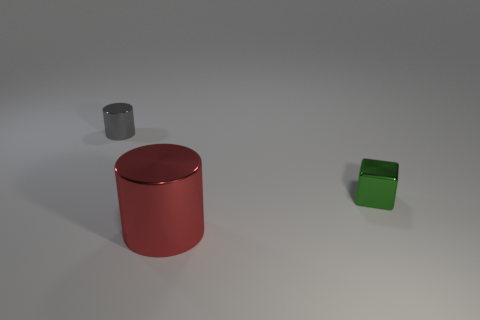What number of rubber things are either cylinders or red objects?
Your answer should be compact. 0. Is the material of the green thing the same as the large red object?
Give a very brief answer. Yes. There is a cylinder right of the metal thing behind the small green block; what is its material?
Your response must be concise. Metal. What number of large things are blue matte things or metallic blocks?
Provide a short and direct response. 0. What size is the gray thing?
Your answer should be compact. Small. Are there more shiny objects right of the small cube than red metallic objects?
Offer a very short reply. No. Are there the same number of large red cylinders behind the gray metallic cylinder and tiny green shiny blocks to the right of the green thing?
Your response must be concise. Yes. What color is the shiny thing that is both to the right of the small gray cylinder and on the left side of the small cube?
Offer a very short reply. Red. Is there anything else that has the same size as the red metallic object?
Offer a very short reply. No. Is the number of large red metal cylinders to the left of the green shiny block greater than the number of gray cylinders that are left of the tiny gray thing?
Provide a short and direct response. Yes. 